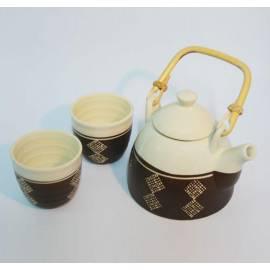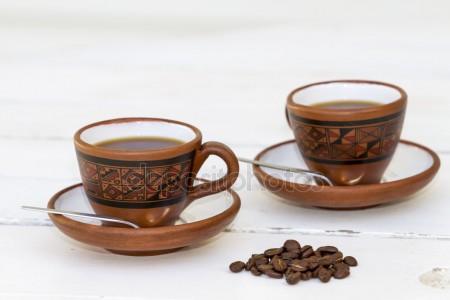The first image is the image on the left, the second image is the image on the right. Evaluate the accuracy of this statement regarding the images: "There is a teapot with cups". Is it true? Answer yes or no. Yes. The first image is the image on the left, the second image is the image on the right. Evaluate the accuracy of this statement regarding the images: "An image of a pair of filled mugs includes a small pile of loose coffee beans.". Is it true? Answer yes or no. Yes. 